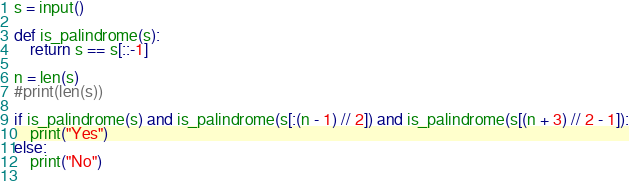Convert code to text. <code><loc_0><loc_0><loc_500><loc_500><_Python_>s = input()

def is_palindrome(s):
    return s == s[::-1]

n = len(s)
#print(len(s))

if is_palindrome(s) and is_palindrome(s[:(n - 1) // 2]) and is_palindrome(s[(n + 3) // 2 - 1]):
    print("Yes")
else:
    print("No")
    </code> 